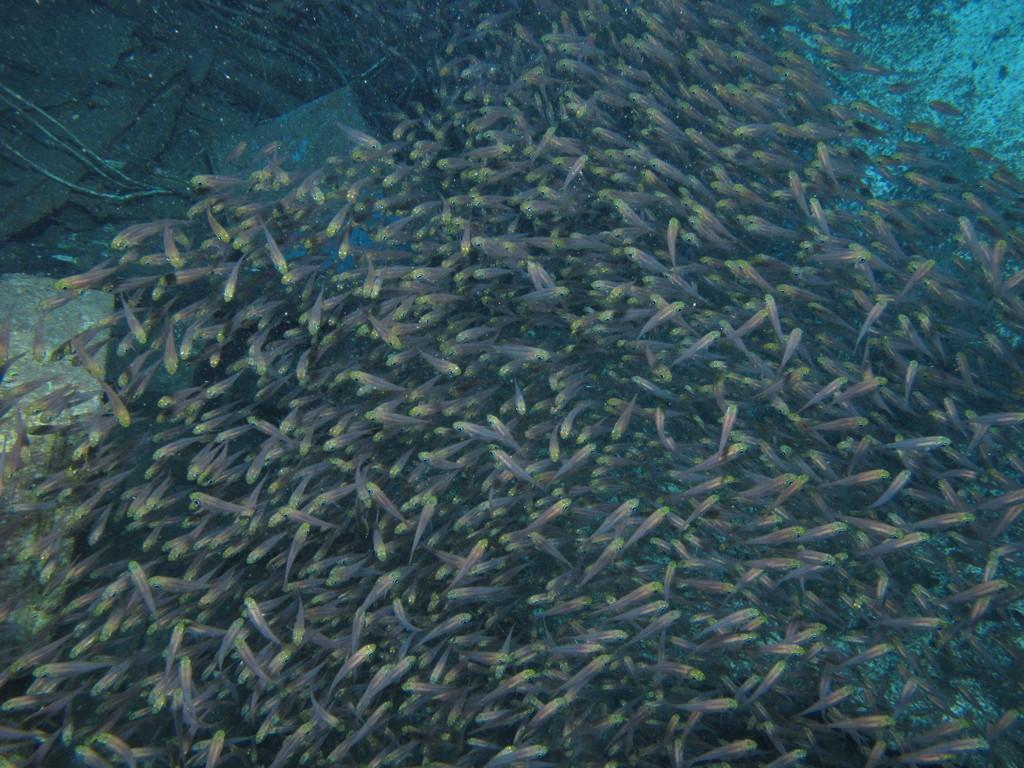In one or two sentences, can you explain what this image depicts? In this image there is a pond, in that pond there are a group of fishes. 